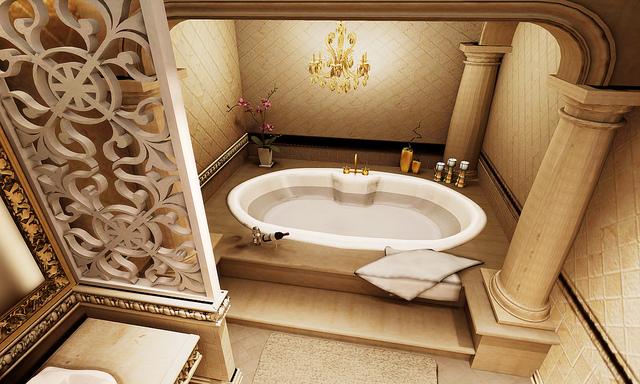Is this bathtub filled with water?
Give a very brief answer. Yes. Where is the faucet?
Keep it brief. Middle of tub. Is the tub sunken?
Keep it brief. Yes. 